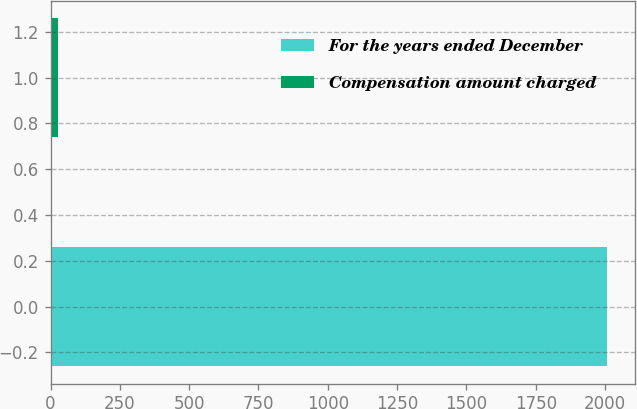<chart> <loc_0><loc_0><loc_500><loc_500><bar_chart><fcel>For the years ended December<fcel>Compensation amount charged<nl><fcel>2007<fcel>26.8<nl></chart> 